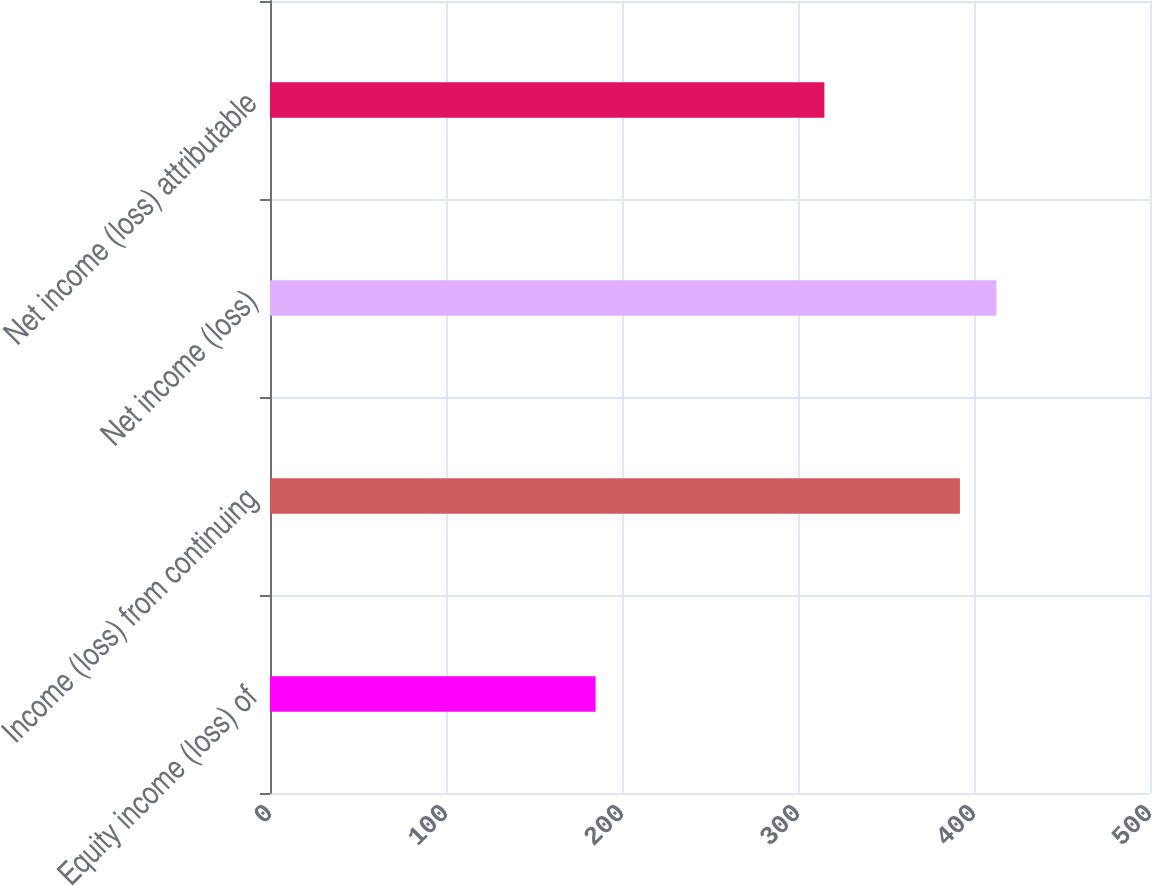Convert chart to OTSL. <chart><loc_0><loc_0><loc_500><loc_500><bar_chart><fcel>Equity income (loss) of<fcel>Income (loss) from continuing<fcel>Net income (loss)<fcel>Net income (loss) attributable<nl><fcel>185<fcel>392<fcel>412.7<fcel>315<nl></chart> 